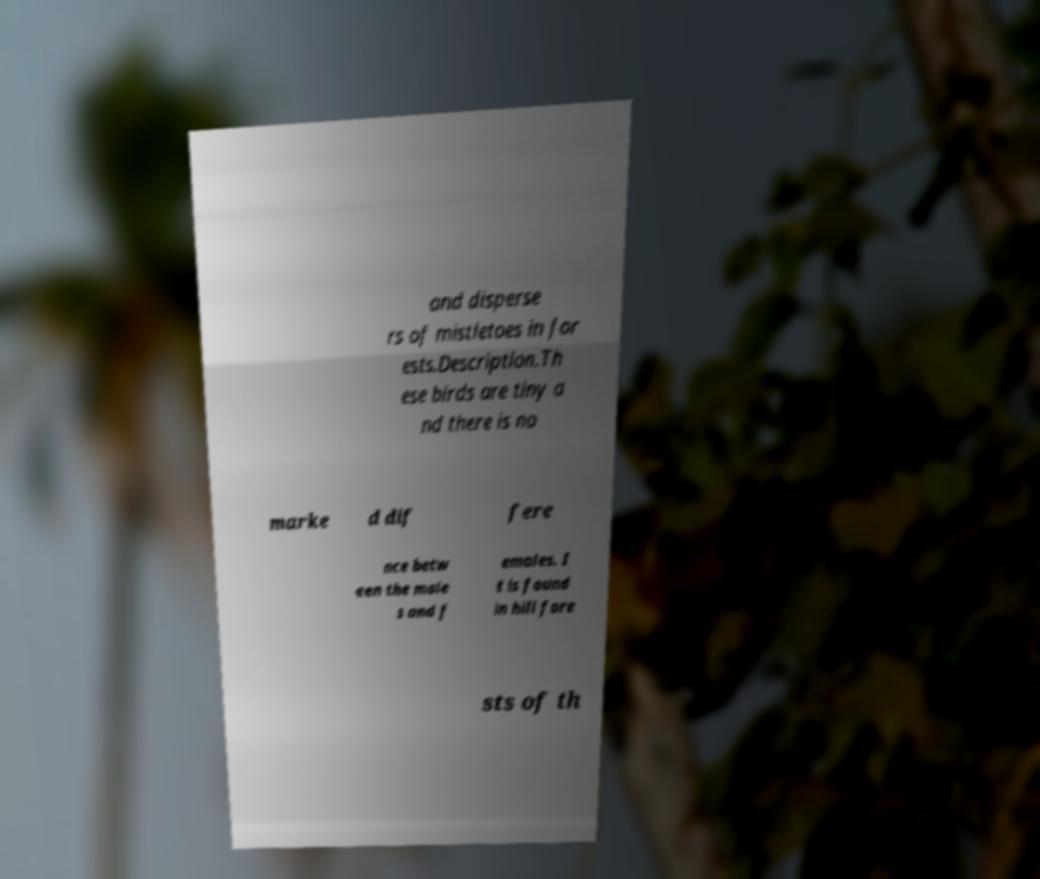What messages or text are displayed in this image? I need them in a readable, typed format. and disperse rs of mistletoes in for ests.Description.Th ese birds are tiny a nd there is no marke d dif fere nce betw een the male s and f emales. I t is found in hill fore sts of th 